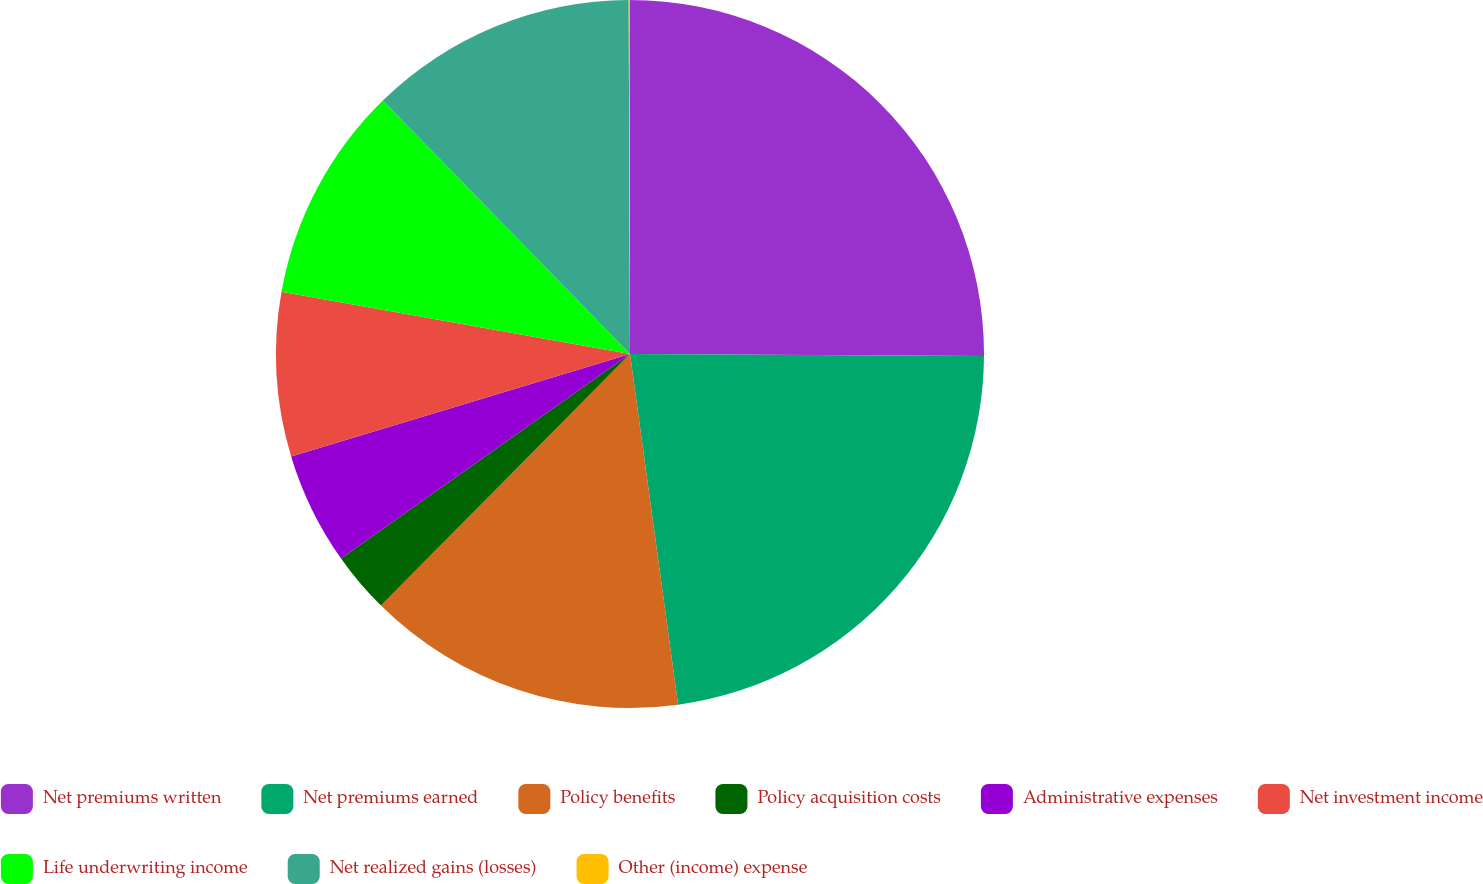Convert chart. <chart><loc_0><loc_0><loc_500><loc_500><pie_chart><fcel>Net premiums written<fcel>Net premiums earned<fcel>Policy benefits<fcel>Policy acquisition costs<fcel>Administrative expenses<fcel>Net investment income<fcel>Life underwriting income<fcel>Net realized gains (losses)<fcel>Other (income) expense<nl><fcel>25.09%<fcel>22.74%<fcel>14.59%<fcel>2.78%<fcel>5.13%<fcel>7.48%<fcel>9.89%<fcel>12.24%<fcel>0.06%<nl></chart> 